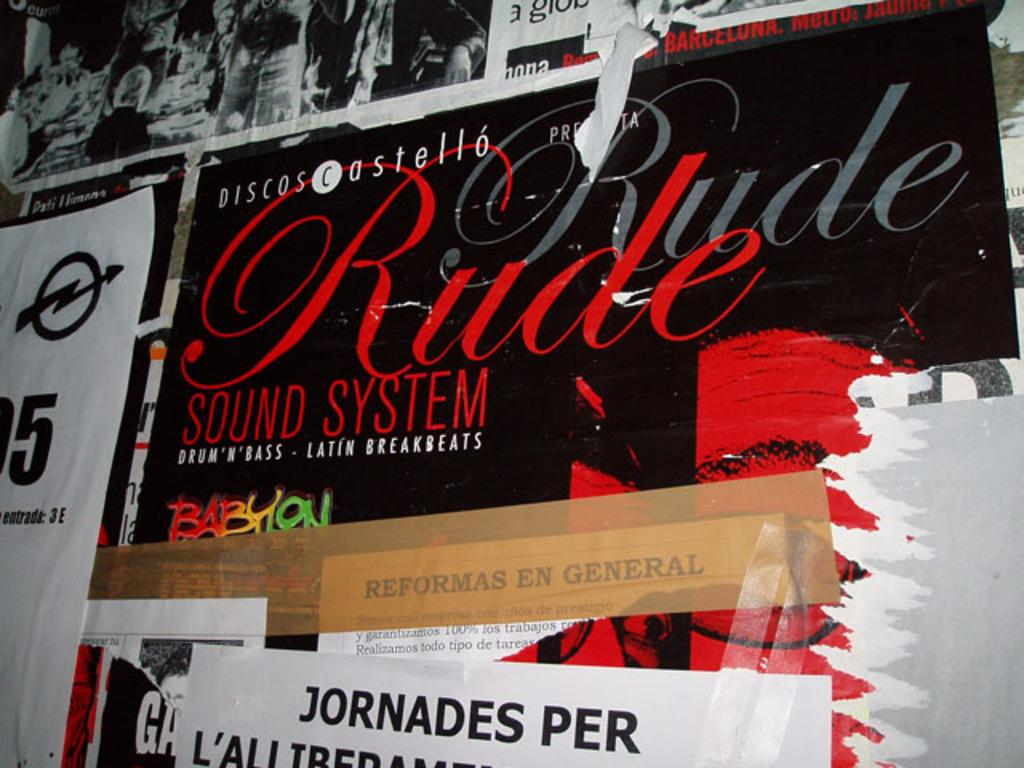<image>
Write a terse but informative summary of the picture. a poster with sound system on it in red 